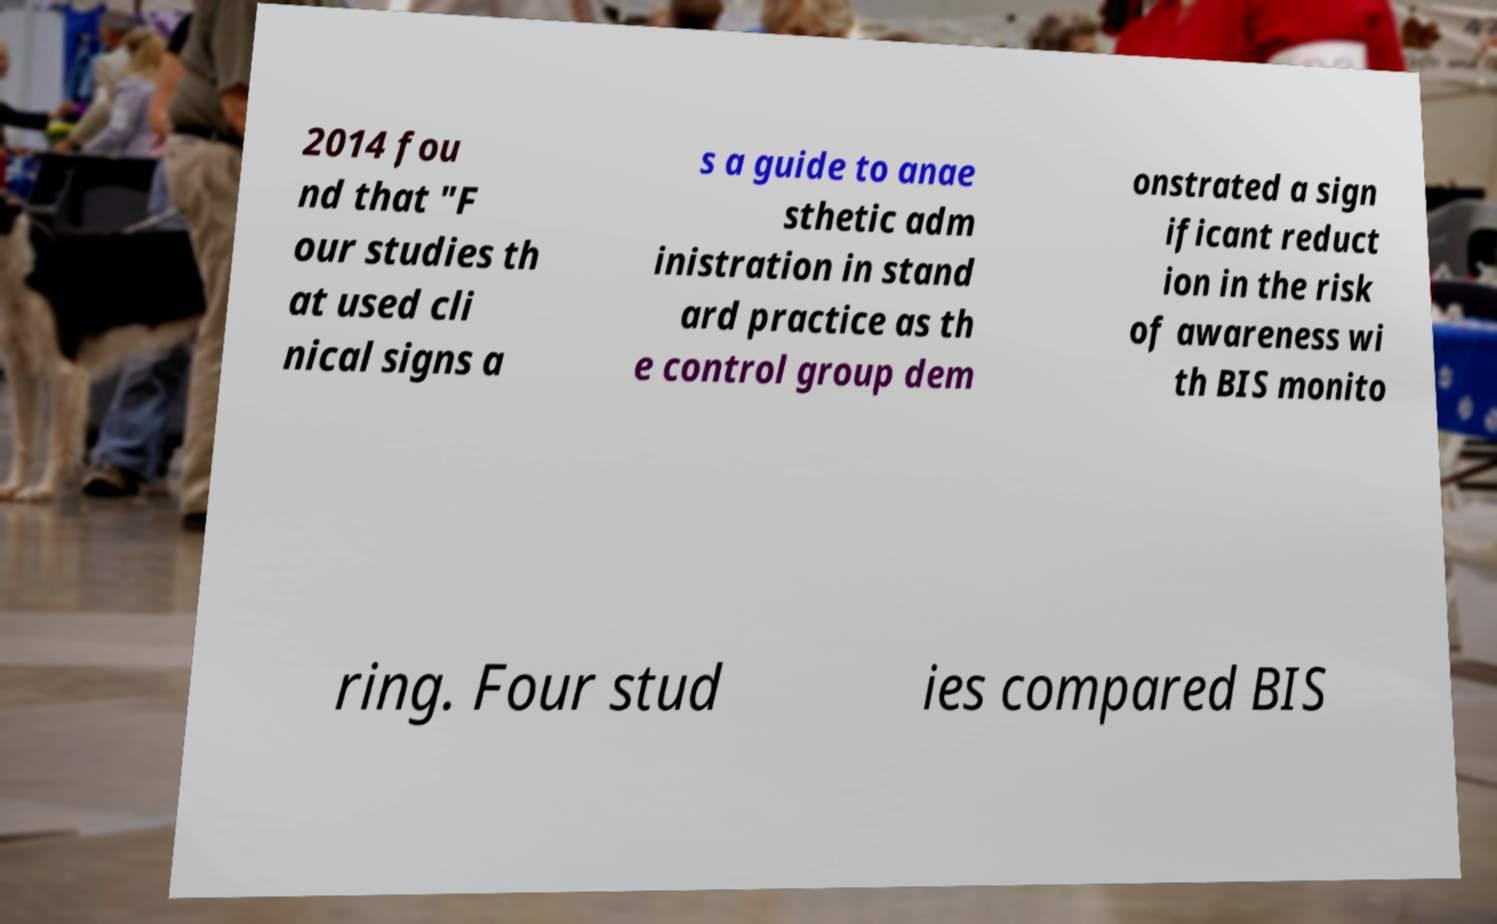I need the written content from this picture converted into text. Can you do that? 2014 fou nd that "F our studies th at used cli nical signs a s a guide to anae sthetic adm inistration in stand ard practice as th e control group dem onstrated a sign ificant reduct ion in the risk of awareness wi th BIS monito ring. Four stud ies compared BIS 